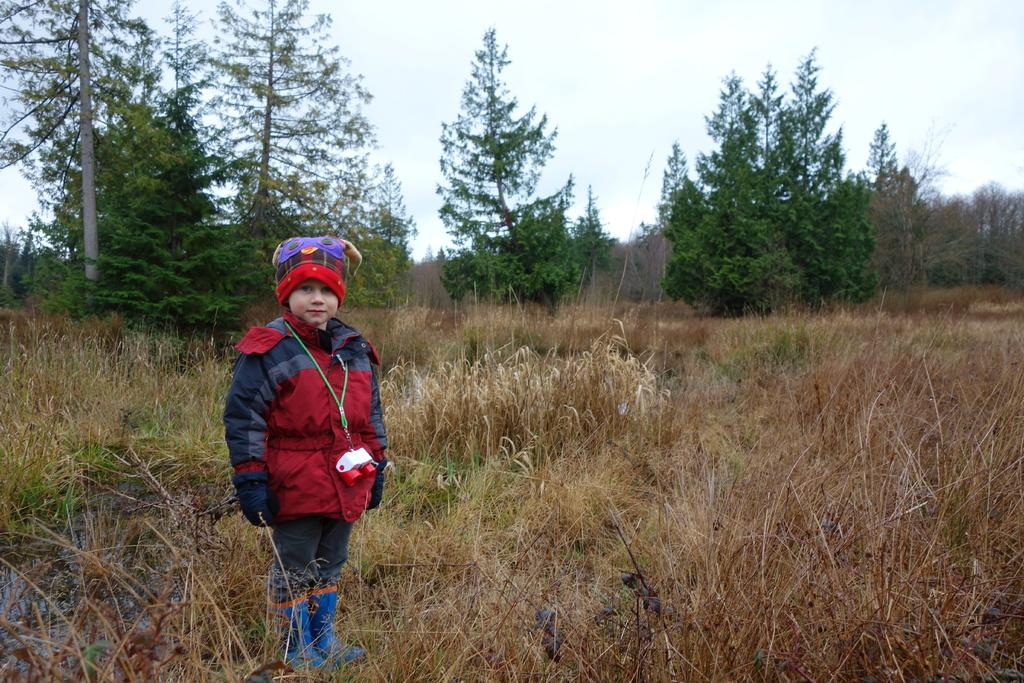What can be seen in the image? There is a child in the image. What is the child wearing? The child is wearing a cap. What is the child holding? The child is holding binoculars. Where is the child standing? The child is standing on a grass field. What is visible in the background of the image? There is a group of trees and a cloudy sky in the background of the image. What type of property does the child own in the image? There is no mention of property ownership in the image; it simply shows a child standing on a grass field with binoculars. 